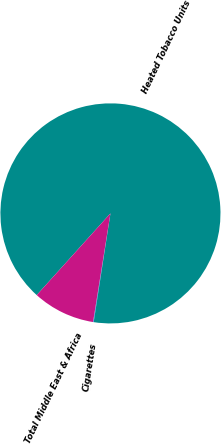Convert chart to OTSL. <chart><loc_0><loc_0><loc_500><loc_500><pie_chart><fcel>Cigarettes<fcel>Heated Tobacco Units<fcel>Total Middle East & Africa<nl><fcel>0.09%<fcel>90.75%<fcel>9.16%<nl></chart> 